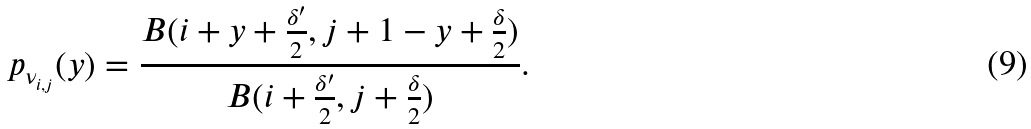<formula> <loc_0><loc_0><loc_500><loc_500>p _ { \nu _ { i , j } } ( y ) = \frac { B ( i + y + \frac { \delta ^ { \prime } } { 2 } , j + 1 - y + \frac { \delta } { 2 } ) } { B ( i + \frac { \delta ^ { \prime } } { 2 } , j + \frac { \delta } { 2 } ) } .</formula> 